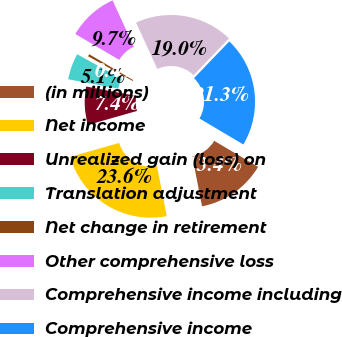<chart> <loc_0><loc_0><loc_500><loc_500><pie_chart><fcel>(in millions)<fcel>Net income<fcel>Unrealized gain (loss) on<fcel>Translation adjustment<fcel>Net change in retirement<fcel>Other comprehensive loss<fcel>Comprehensive income including<fcel>Comprehensive income<nl><fcel>13.43%<fcel>23.64%<fcel>7.38%<fcel>5.07%<fcel>0.44%<fcel>9.69%<fcel>19.02%<fcel>21.33%<nl></chart> 